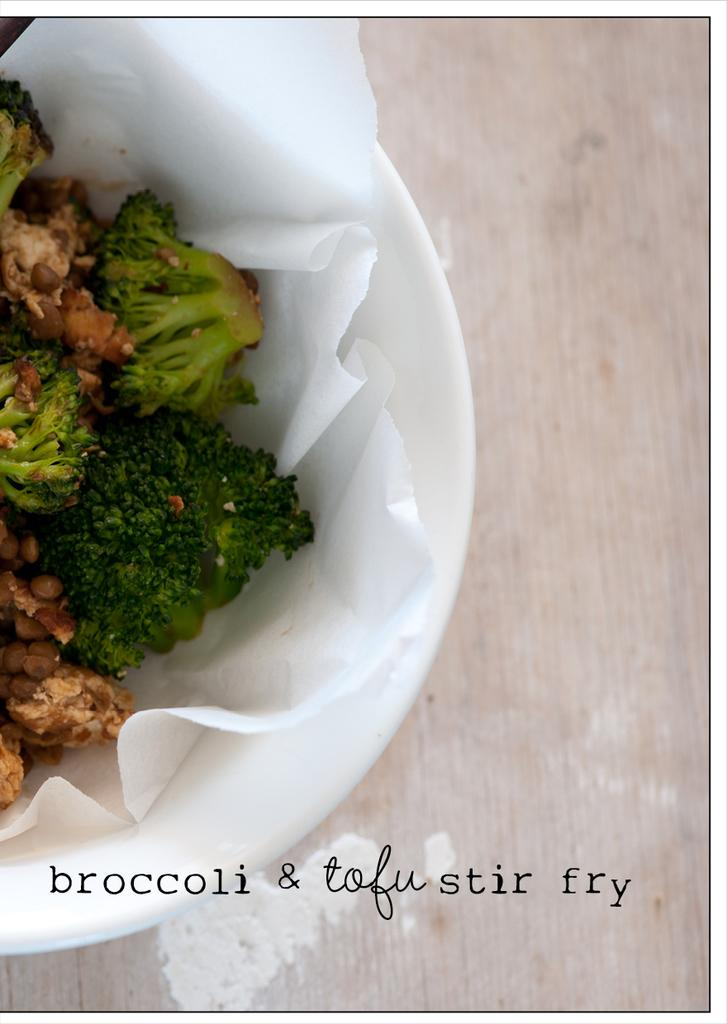What type of dish is featured in the image? There is a fried broccoli dish in the image. How is the dish presented? The dish is in a bowl. On what surface is the bowl placed? The bowl is kept on a wooden table. How many feet are visible in the image? There are no feet visible in the image. What type of paste is used to prepare the dish in the image? The provided facts do not mention any paste being used in the preparation of the dish. 